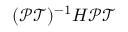<formula> <loc_0><loc_0><loc_500><loc_500>\mathcal { ( P T ) } ^ { - 1 } H \mathcal { P T }</formula> 